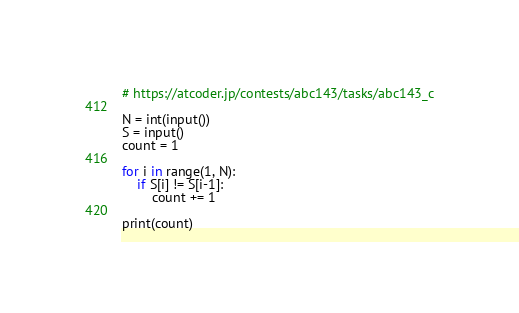Convert code to text. <code><loc_0><loc_0><loc_500><loc_500><_Python_># https://atcoder.jp/contests/abc143/tasks/abc143_c

N = int(input())
S = input()
count = 1

for i in range(1, N):
    if S[i] != S[i-1]:
        count += 1

print(count)</code> 